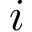Convert formula to latex. <formula><loc_0><loc_0><loc_500><loc_500>i</formula> 